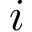Convert formula to latex. <formula><loc_0><loc_0><loc_500><loc_500>i</formula> 